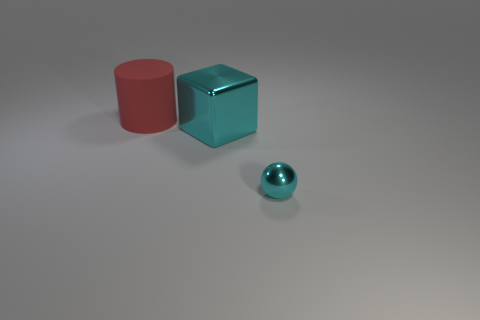Are there any other things that are the same material as the large cylinder?
Provide a succinct answer. No. There is a small ball that is the same color as the block; what material is it?
Keep it short and to the point. Metal. Is there anything else that is the same size as the red matte cylinder?
Provide a succinct answer. Yes. There is a tiny metallic sphere; are there any small cyan spheres in front of it?
Your response must be concise. No. Do the large object behind the big cyan cube and the big thing that is right of the big red matte thing have the same color?
Make the answer very short. No. Is there another object of the same shape as the big red rubber object?
Give a very brief answer. No. What number of other objects are the same color as the rubber cylinder?
Your answer should be very brief. 0. The large thing in front of the rubber cylinder that is behind the cyan object that is to the left of the tiny cyan shiny sphere is what color?
Your response must be concise. Cyan. Are there an equal number of big red matte things behind the large red thing and small blue rubber cubes?
Make the answer very short. Yes. Does the metal thing that is behind the cyan ball have the same size as the large red cylinder?
Keep it short and to the point. Yes. 